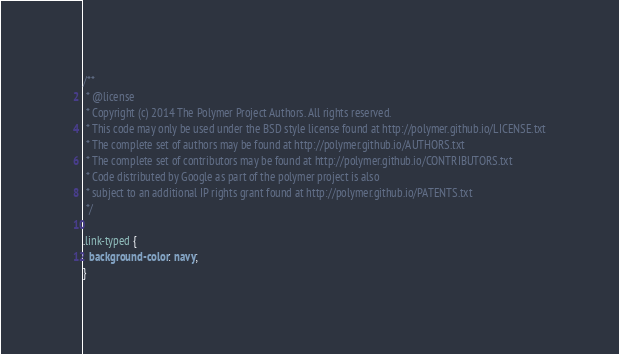<code> <loc_0><loc_0><loc_500><loc_500><_CSS_>/**
 * @license
 * Copyright (c) 2014 The Polymer Project Authors. All rights reserved.
 * This code may only be used under the BSD style license found at http://polymer.github.io/LICENSE.txt
 * The complete set of authors may be found at http://polymer.github.io/AUTHORS.txt
 * The complete set of contributors may be found at http://polymer.github.io/CONTRIBUTORS.txt
 * Code distributed by Google as part of the polymer project is also
 * subject to an additional IP rights grant found at http://polymer.github.io/PATENTS.txt
 */

.link-typed {
  background-color: navy;
}
</code> 